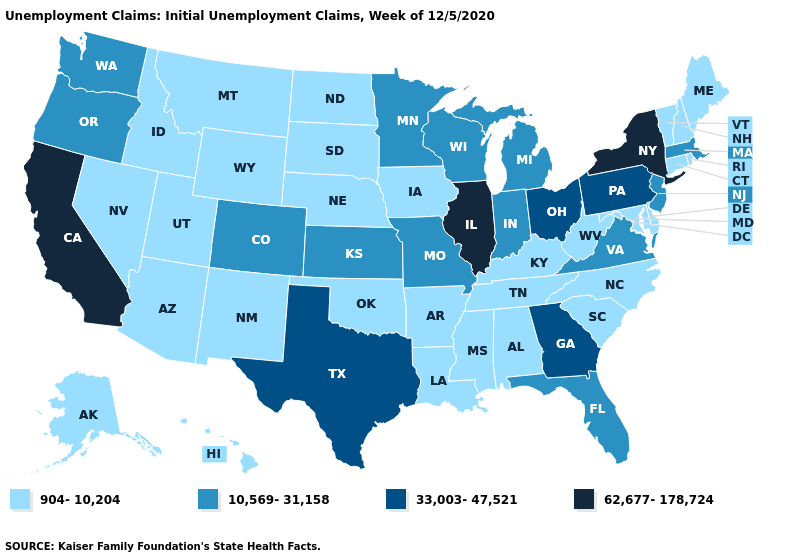Name the states that have a value in the range 904-10,204?
Answer briefly. Alabama, Alaska, Arizona, Arkansas, Connecticut, Delaware, Hawaii, Idaho, Iowa, Kentucky, Louisiana, Maine, Maryland, Mississippi, Montana, Nebraska, Nevada, New Hampshire, New Mexico, North Carolina, North Dakota, Oklahoma, Rhode Island, South Carolina, South Dakota, Tennessee, Utah, Vermont, West Virginia, Wyoming. Does South Dakota have the lowest value in the MidWest?
Quick response, please. Yes. Does the first symbol in the legend represent the smallest category?
Keep it brief. Yes. Among the states that border Utah , which have the lowest value?
Keep it brief. Arizona, Idaho, Nevada, New Mexico, Wyoming. Does Oklahoma have the lowest value in the USA?
Write a very short answer. Yes. What is the value of Wisconsin?
Quick response, please. 10,569-31,158. What is the highest value in the USA?
Give a very brief answer. 62,677-178,724. What is the value of Idaho?
Keep it brief. 904-10,204. Name the states that have a value in the range 62,677-178,724?
Concise answer only. California, Illinois, New York. What is the value of North Carolina?
Short answer required. 904-10,204. What is the value of North Carolina?
Be succinct. 904-10,204. What is the value of West Virginia?
Keep it brief. 904-10,204. Does South Carolina have the same value as Utah?
Answer briefly. Yes. Does Minnesota have the lowest value in the MidWest?
Write a very short answer. No. Name the states that have a value in the range 904-10,204?
Be succinct. Alabama, Alaska, Arizona, Arkansas, Connecticut, Delaware, Hawaii, Idaho, Iowa, Kentucky, Louisiana, Maine, Maryland, Mississippi, Montana, Nebraska, Nevada, New Hampshire, New Mexico, North Carolina, North Dakota, Oklahoma, Rhode Island, South Carolina, South Dakota, Tennessee, Utah, Vermont, West Virginia, Wyoming. 